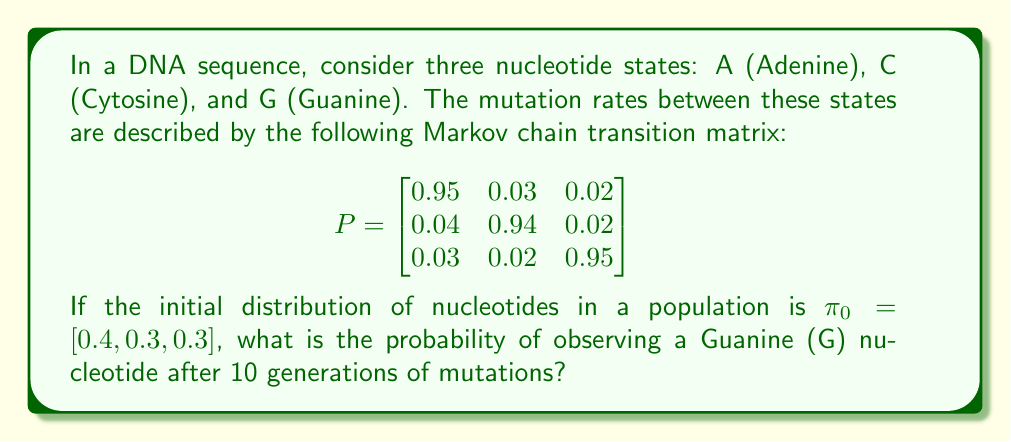Teach me how to tackle this problem. To solve this problem, we need to use the properties of Markov chains and matrix multiplication. Let's break it down step by step:

1) The initial distribution is given as $\pi_0 = [0.4, 0.3, 0.3]$.

2) We need to find the distribution after 10 generations, which is given by:

   $\pi_{10} = \pi_0 \cdot P^{10}$

3) To calculate $P^{10}$, we can use the eigenvector decomposition method:

   $P = V \cdot D \cdot V^{-1}$

   Where $D$ is a diagonal matrix of eigenvalues, and $V$ is a matrix of eigenvectors.

4) Using a computer algebra system, we can calculate the eigenvalues and eigenvectors:

   Eigenvalues: $\lambda_1 = 1$, $\lambda_2 \approx 0.92$, $\lambda_3 \approx 0.92$

   Eigenvectors:
   $$V \approx \begin{bmatrix}
   0.5774 & -0.7040 & -0.4629 \\
   0.5774 & 0.7101 & -0.4629 \\
   0.5774 & -0.0061 & 0.7559
   \end{bmatrix}$$

5) Now we can calculate $P^{10}$:

   $P^{10} = V \cdot D^{10} \cdot V^{-1}$

6) Performing this calculation (which is computationally intensive and typically done with software), we get:

   $$P^{10} \approx \begin{bmatrix}
   0.3458 & 0.3271 & 0.3271 \\
   0.3271 & 0.3458 & 0.3271 \\
   0.3271 & 0.3271 & 0.3458
   \end{bmatrix}$$

7) Now we can calculate $\pi_{10}$:

   $\pi_{10} = [0.4, 0.3, 0.3] \cdot \begin{bmatrix}
   0.3458 & 0.3271 & 0.3271 \\
   0.3271 & 0.3458 & 0.3271 \\
   0.3271 & 0.3271 & 0.3458
   \end{bmatrix}$

8) Performing this matrix multiplication:

   $\pi_{10} \approx [0.3339, 0.3331, 0.3330]$

9) The probability of observing a Guanine (G) nucleotide after 10 generations is the third element of this vector.
Answer: The probability of observing a Guanine (G) nucleotide after 10 generations is approximately 0.3330 or 33.30%. 